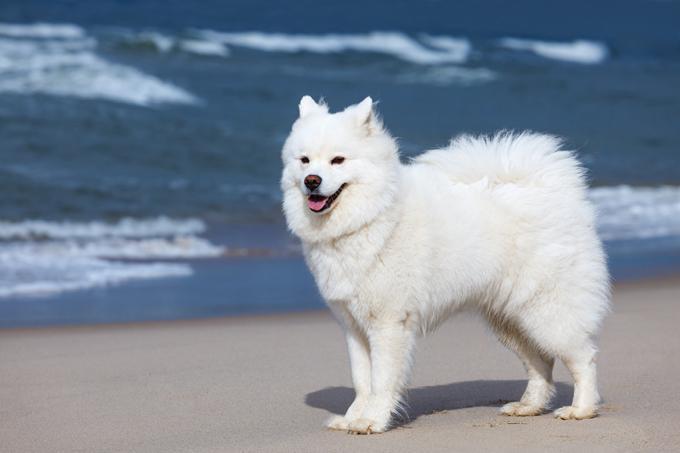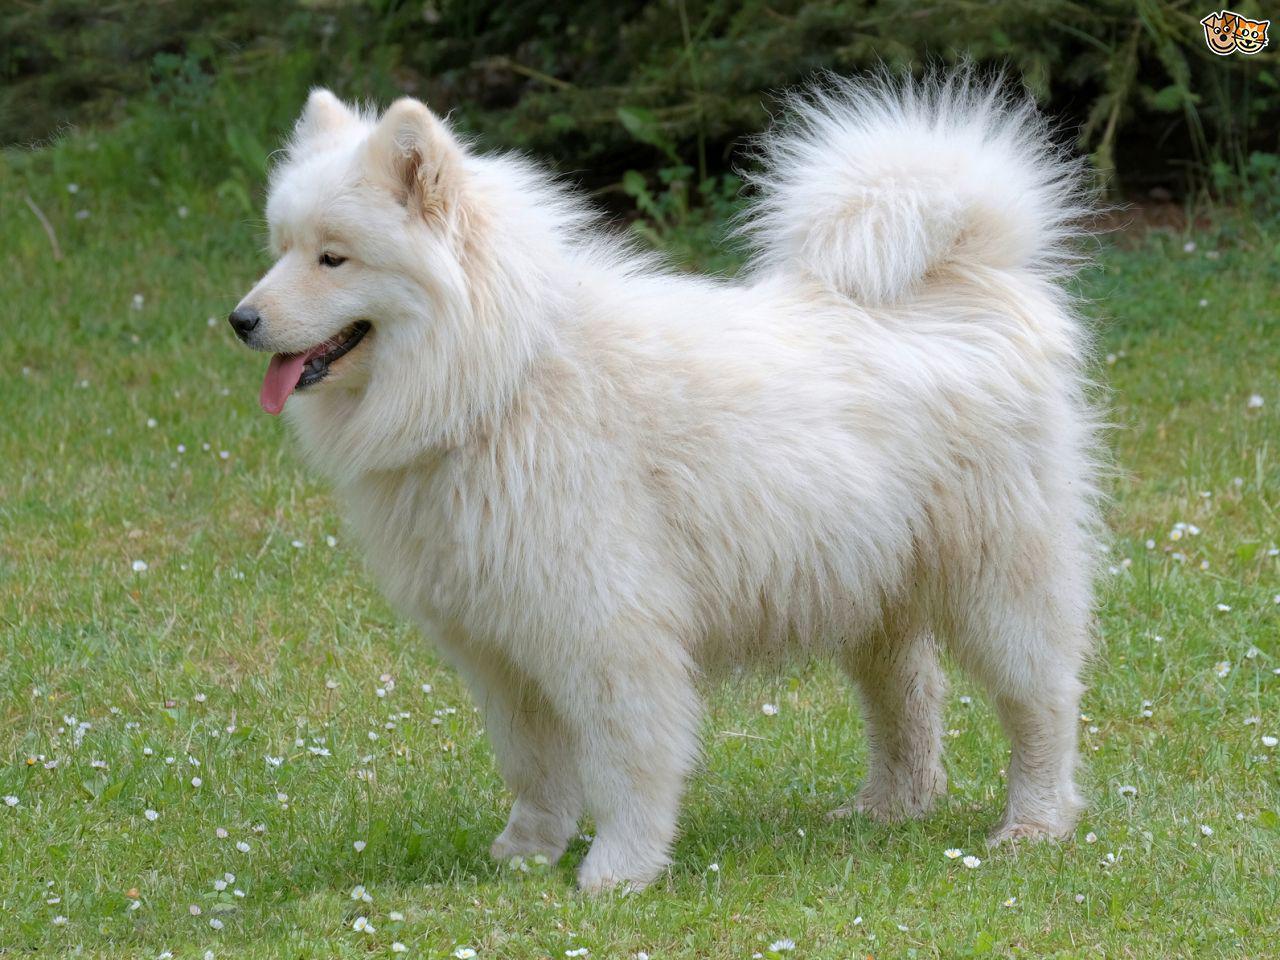The first image is the image on the left, the second image is the image on the right. Examine the images to the left and right. Is the description "There is an adult dog and a puppy in the left image." accurate? Answer yes or no. No. 